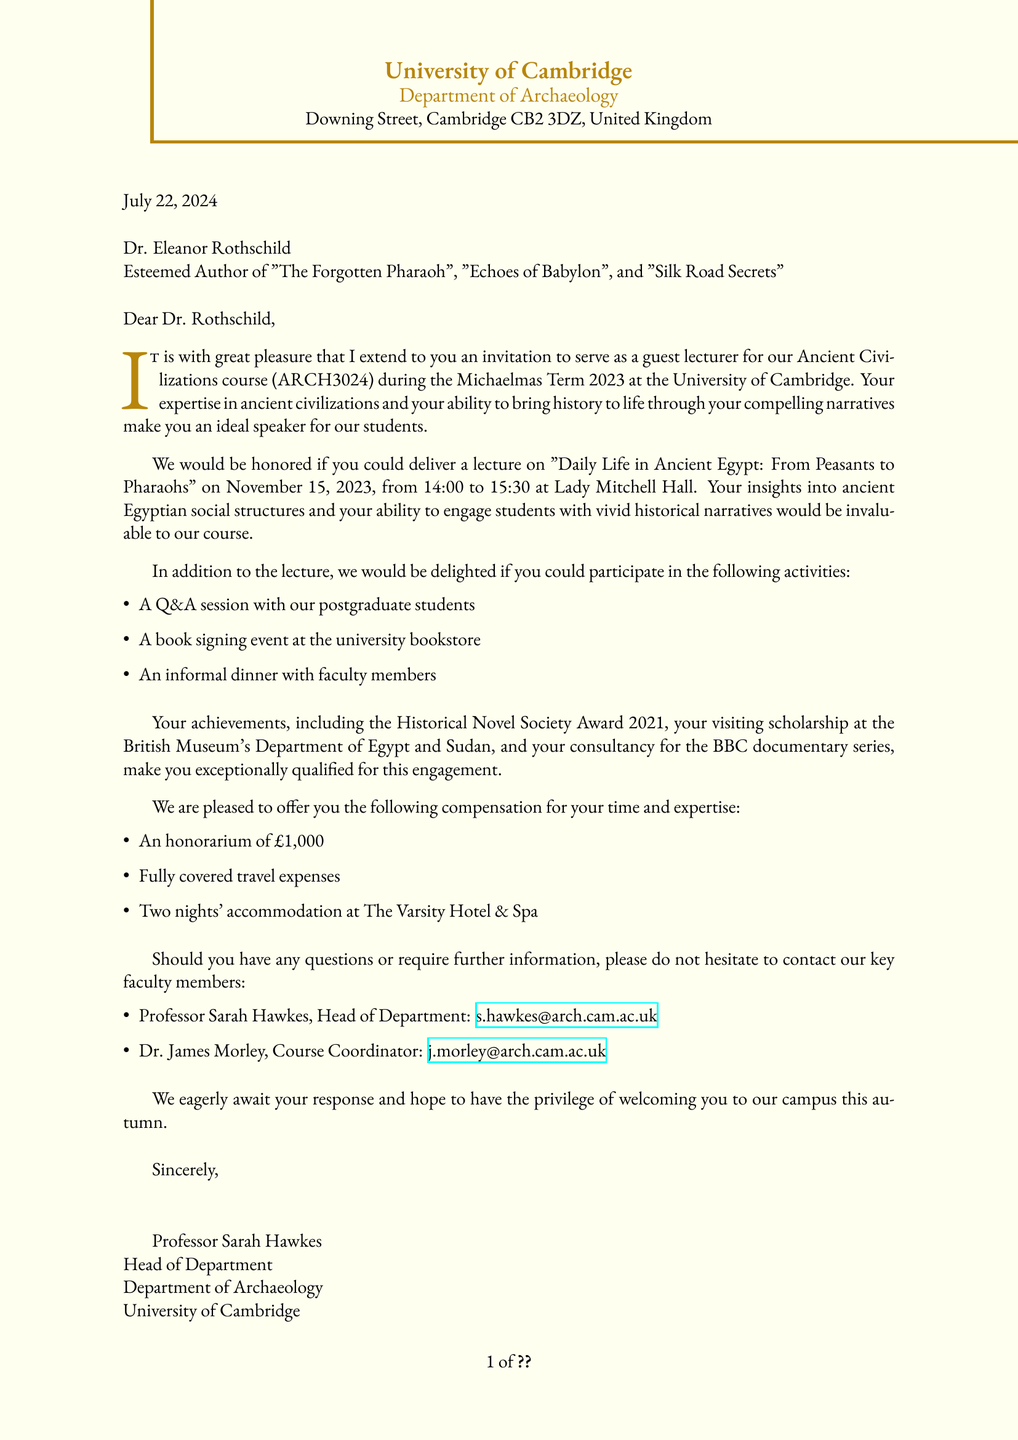What is the name of the university? The name of the university is mentioned at the beginning of the document.
Answer: University of Cambridge Who is the recipient of the letter? The letter is addressed to Dr. Eleanor Rothschild, as stated at the beginning of the correspondence.
Answer: Dr. Eleanor Rothschild What is the date of the lecture? The lecture date is specified in the document, directly indicating when the event is scheduled.
Answer: November 15, 2023 What will be the topic of the lecture? The topic of the lecture is explicitly mentioned in the invitation section of the document.
Answer: Daily Life in Ancient Egypt: From Peasants to Pharaohs How long is the lecture scheduled to last? The duration of the lecture is provided directly in the details section of the document.
Answer: 90 minutes What is the honorarium amount offered? The compensation section of the document specifies the honorarium amount to be provided.
Answer: £1,000 What activity follows the lecture for postgraduate students? The activities planned include a Q&A session, which is listed among the additional activities.
Answer: Q&A session with postgraduate students Who is the Head of the Department? The document identifies the Head of Department in the contact section with their name and title.
Answer: Professor Sarah Hawkes What is included in the accommodation offer? Details about accommodation are mentioned in the compensation section, specifically what is being provided.
Answer: Two nights at The Varsity Hotel & Spa 